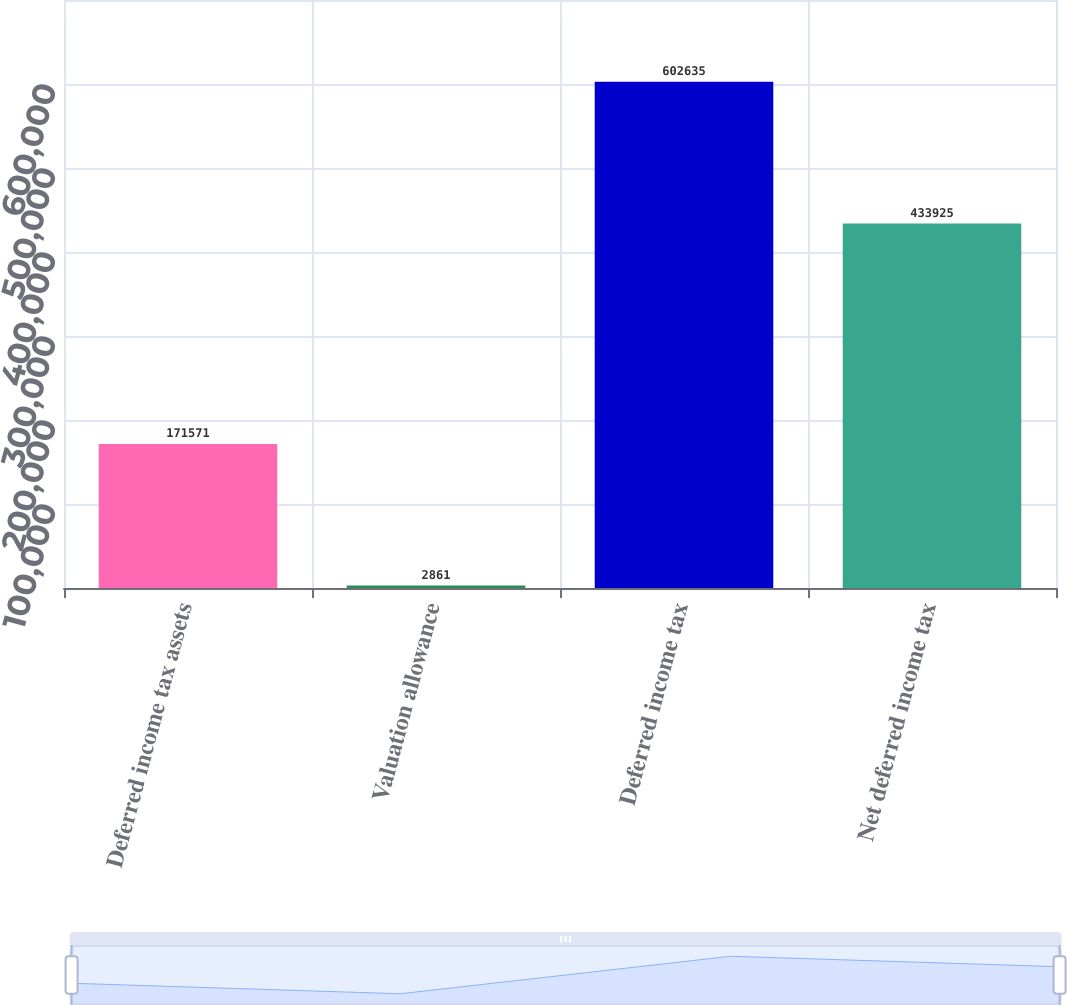Convert chart. <chart><loc_0><loc_0><loc_500><loc_500><bar_chart><fcel>Deferred income tax assets<fcel>Valuation allowance<fcel>Deferred income tax<fcel>Net deferred income tax<nl><fcel>171571<fcel>2861<fcel>602635<fcel>433925<nl></chart> 